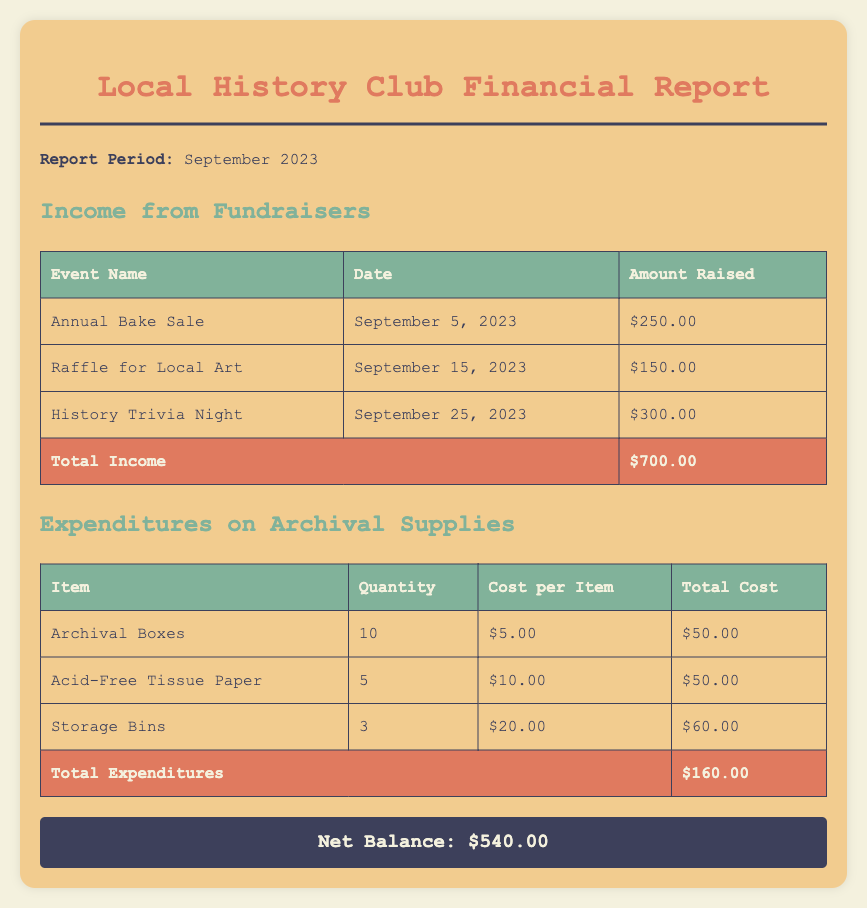What was the total amount raised from fundraisers? The total amount raised from fundraisers is listed at the bottom of the income table, which sums up all events.
Answer: $700.00 How much did the club spend on archival supplies? The total amount spent on archival supplies can be found at the end of the expenditures table, summarizing all items purchased.
Answer: $160.00 What is the date of the Annual Bake Sale? The date of the Annual Bake Sale is specified in the income table for the event.
Answer: September 5, 2023 Which event raised the most money? The event that raised the most money can be determined by comparing the amounts in the income table.
Answer: History Trivia Night What is the net balance for the month? The net balance is presented at the bottom of the report, summarizing the difference between total income and total expenditures.
Answer: $540.00 How many Archival Boxes were purchased? The quantity of Archival Boxes is found in the expenditures table under the item description.
Answer: 10 What is the cost per item for Acid-Free Tissue Paper? The cost per item for Acid-Free Tissue Paper is given in the expenditures table.
Answer: $10.00 What is the total cost for Storage Bins? The total cost for Storage Bins is calculated based on the quantity and cost per item, shown in the expenditures table.
Answer: $60.00 